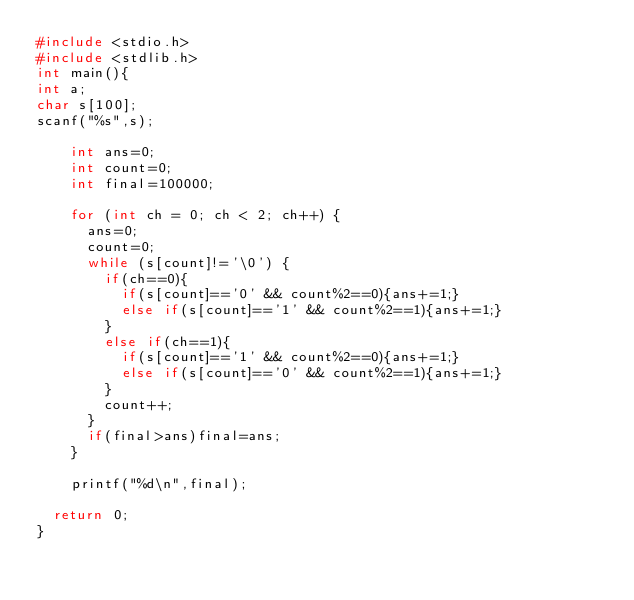Convert code to text. <code><loc_0><loc_0><loc_500><loc_500><_C_>#include <stdio.h>
#include <stdlib.h>
int main(){
int a;
char s[100];
scanf("%s",s);

    int ans=0;
    int count=0;
    int final=100000;

    for (int ch = 0; ch < 2; ch++) {
      ans=0;
      count=0;
      while (s[count]!='\0') {
        if(ch==0){
          if(s[count]=='0' && count%2==0){ans+=1;}
          else if(s[count]=='1' && count%2==1){ans+=1;}
        }
        else if(ch==1){
          if(s[count]=='1' && count%2==0){ans+=1;}
          else if(s[count]=='0' && count%2==1){ans+=1;}
        }
        count++;
      }
      if(final>ans)final=ans;
    }

    printf("%d\n",final);

  return 0;
}
</code> 